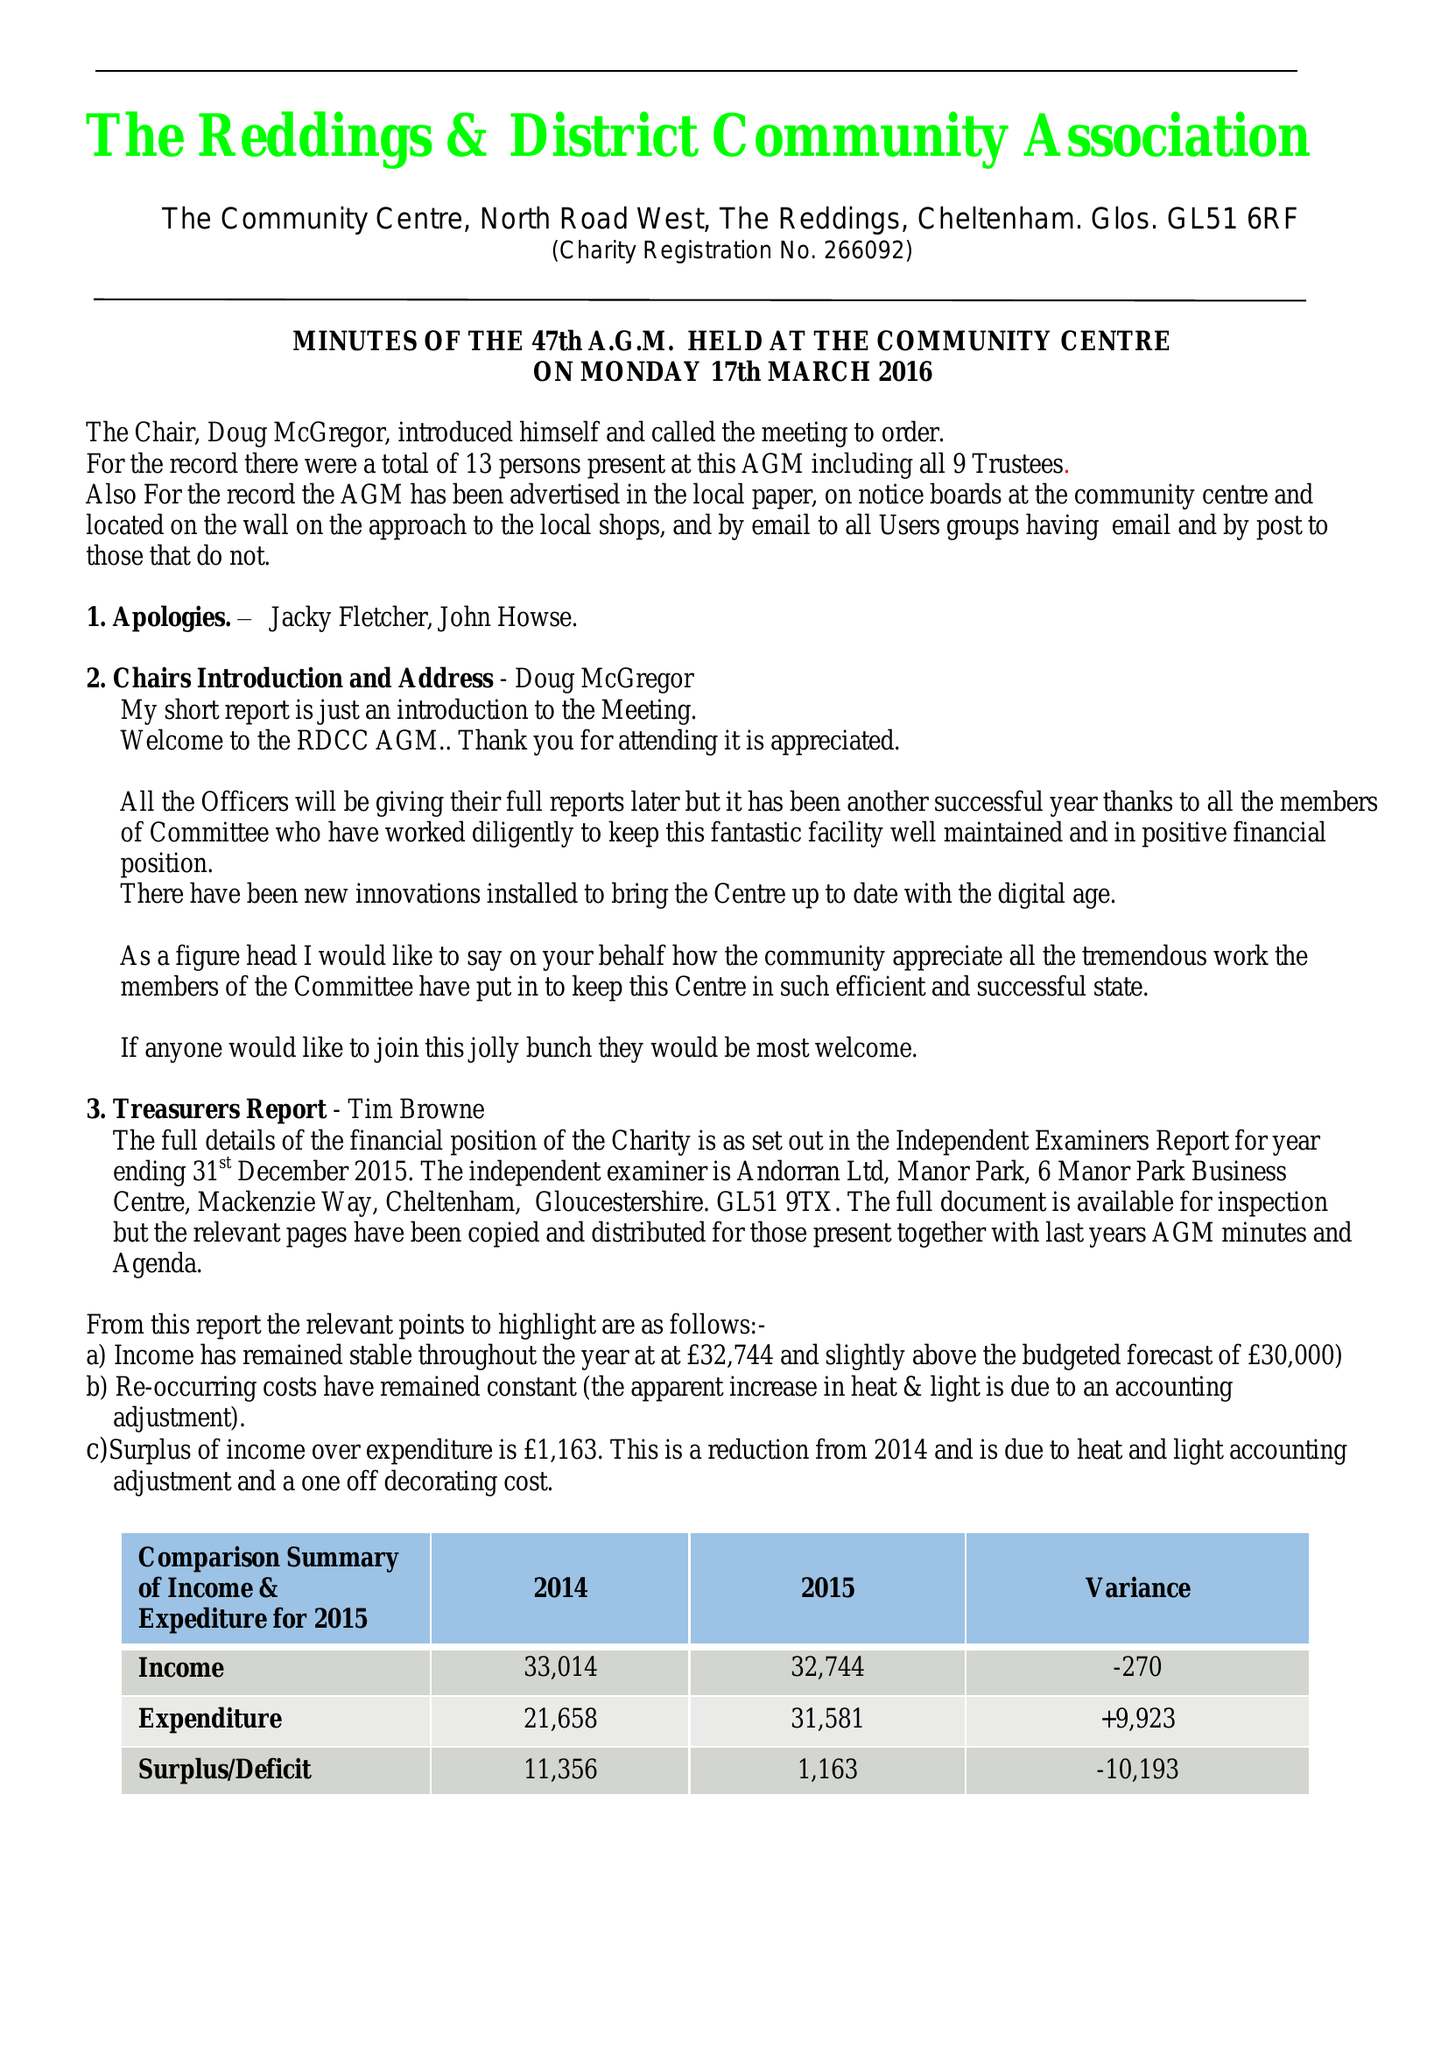What is the value for the income_annually_in_british_pounds?
Answer the question using a single word or phrase. 32744.00 